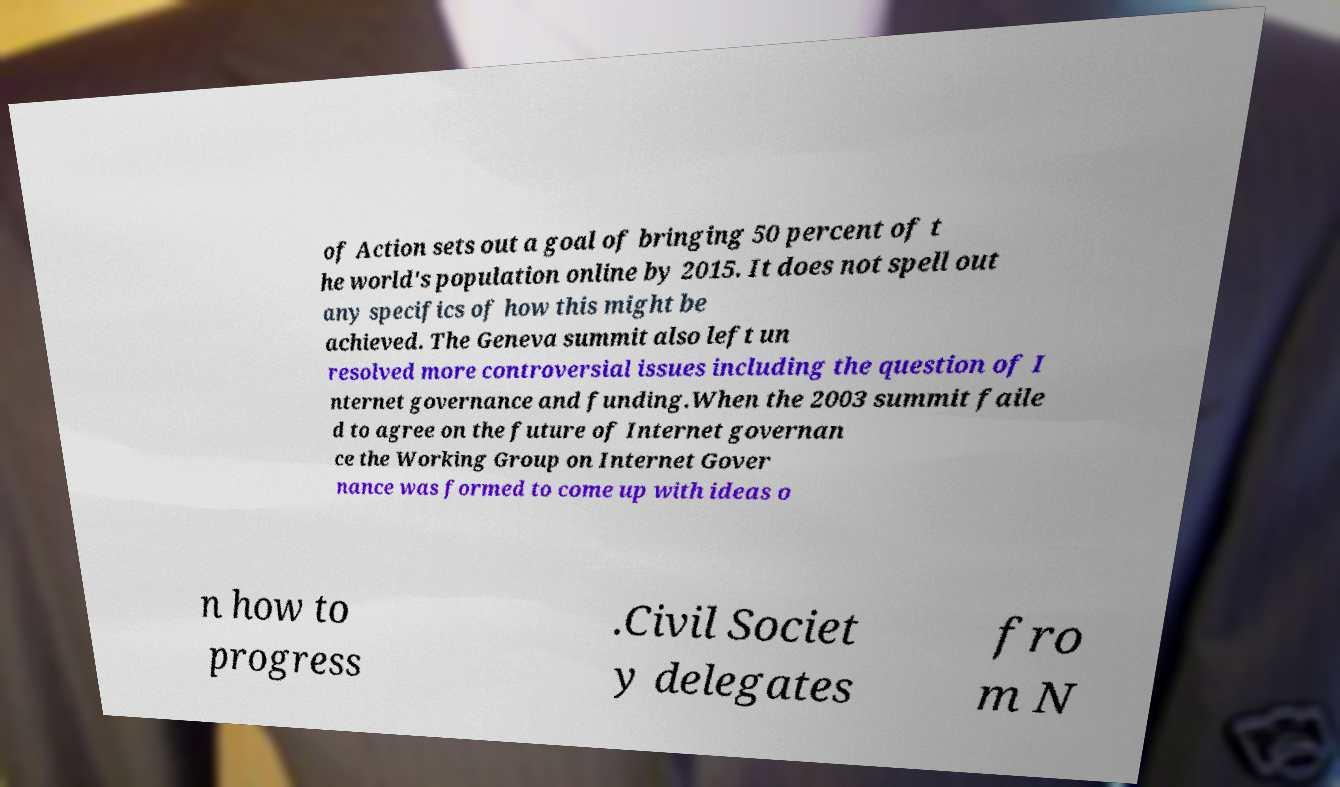Please identify and transcribe the text found in this image. of Action sets out a goal of bringing 50 percent of t he world's population online by 2015. It does not spell out any specifics of how this might be achieved. The Geneva summit also left un resolved more controversial issues including the question of I nternet governance and funding.When the 2003 summit faile d to agree on the future of Internet governan ce the Working Group on Internet Gover nance was formed to come up with ideas o n how to progress .Civil Societ y delegates fro m N 